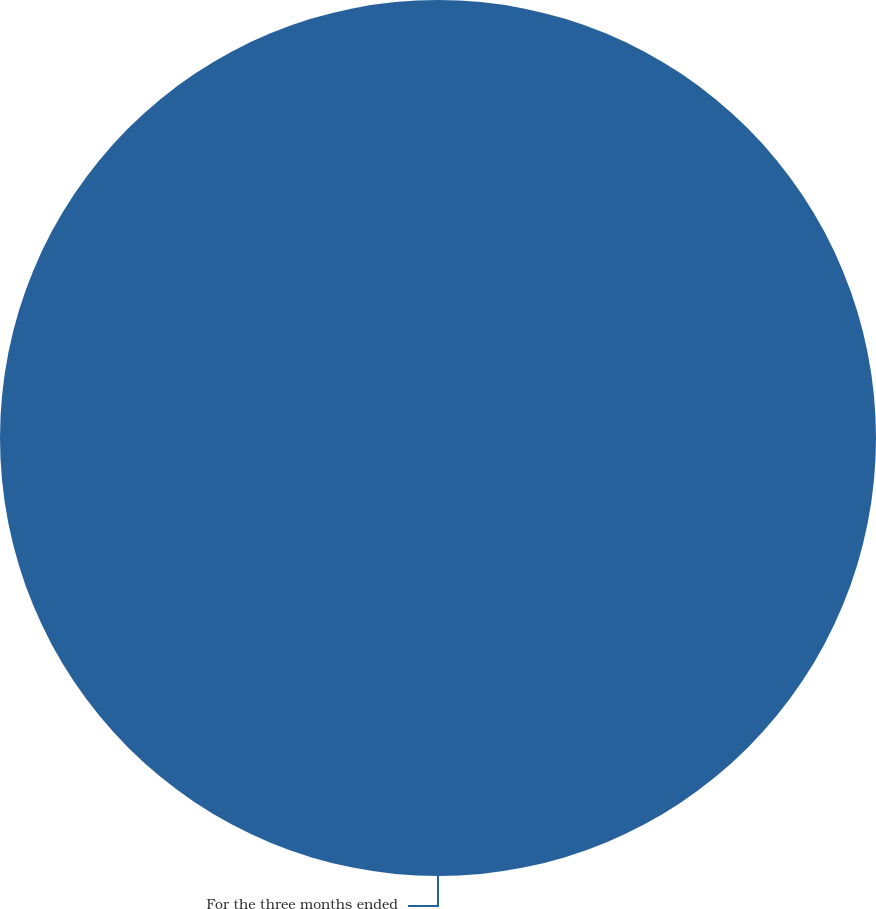Convert chart. <chart><loc_0><loc_0><loc_500><loc_500><pie_chart><fcel>For the three months ended<nl><fcel>100.0%<nl></chart> 